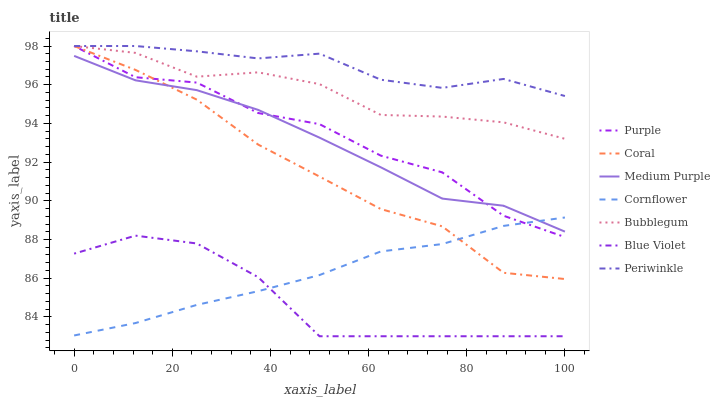Does Blue Violet have the minimum area under the curve?
Answer yes or no. Yes. Does Periwinkle have the maximum area under the curve?
Answer yes or no. Yes. Does Purple have the minimum area under the curve?
Answer yes or no. No. Does Purple have the maximum area under the curve?
Answer yes or no. No. Is Cornflower the smoothest?
Answer yes or no. Yes. Is Purple the roughest?
Answer yes or no. Yes. Is Coral the smoothest?
Answer yes or no. No. Is Coral the roughest?
Answer yes or no. No. Does Purple have the lowest value?
Answer yes or no. No. Does Periwinkle have the highest value?
Answer yes or no. Yes. Does Medium Purple have the highest value?
Answer yes or no. No. Is Medium Purple less than Periwinkle?
Answer yes or no. Yes. Is Periwinkle greater than Blue Violet?
Answer yes or no. Yes. Does Bubblegum intersect Coral?
Answer yes or no. Yes. Is Bubblegum less than Coral?
Answer yes or no. No. Is Bubblegum greater than Coral?
Answer yes or no. No. Does Medium Purple intersect Periwinkle?
Answer yes or no. No. 